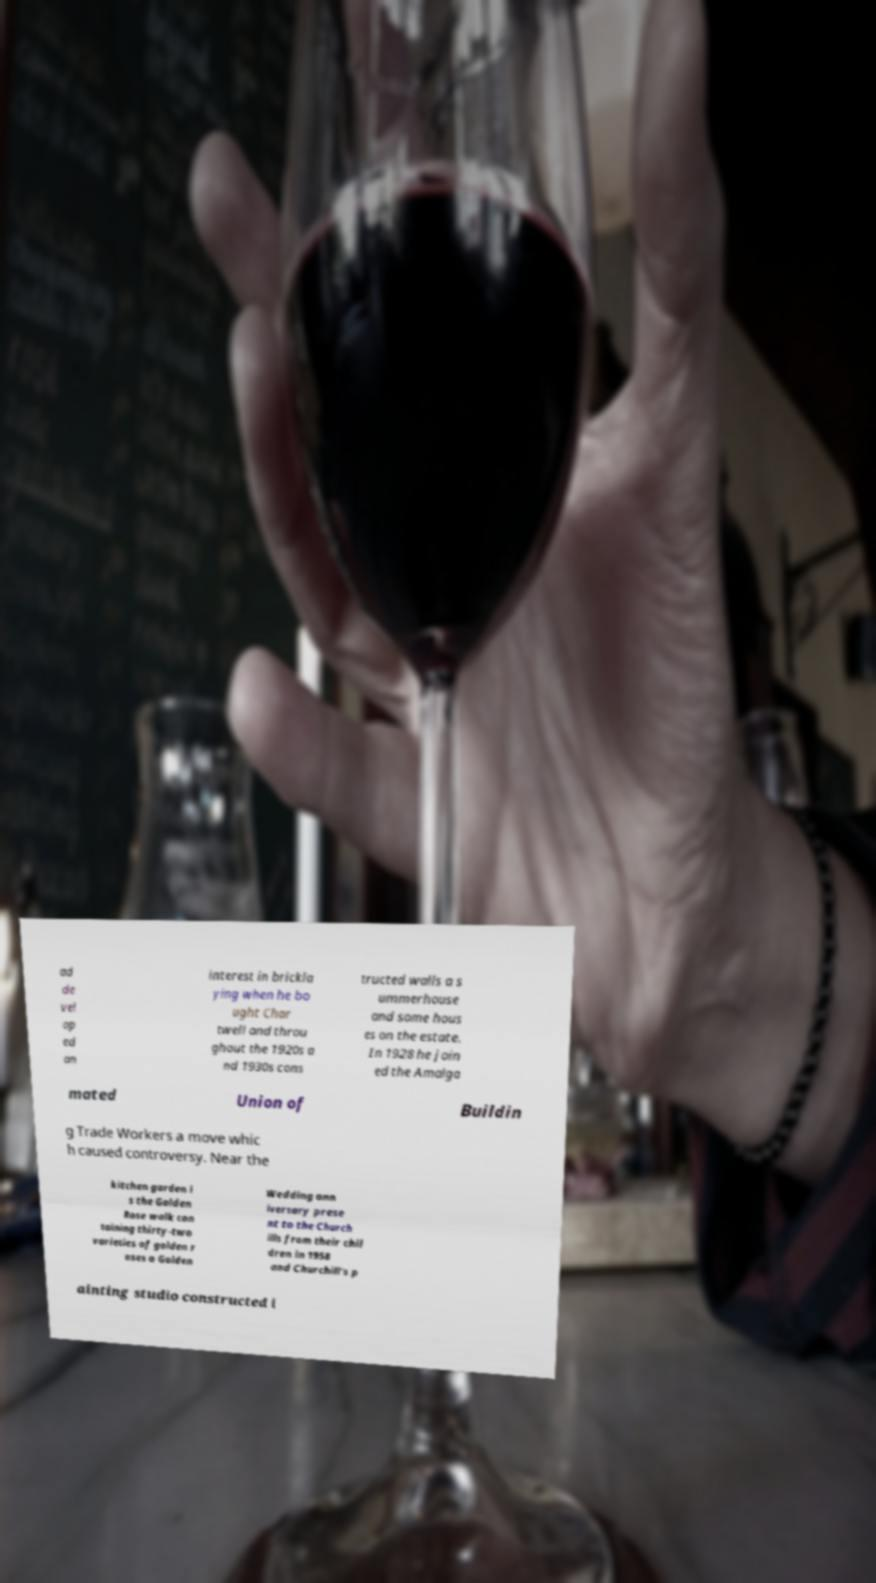Can you accurately transcribe the text from the provided image for me? ad de vel op ed an interest in brickla ying when he bo ught Char twell and throu ghout the 1920s a nd 1930s cons tructed walls a s ummerhouse and some hous es on the estate. In 1928 he join ed the Amalga mated Union of Buildin g Trade Workers a move whic h caused controversy. Near the kitchen garden i s the Golden Rose walk con taining thirty-two varieties of golden r oses a Golden Wedding ann iversary prese nt to the Church ills from their chil dren in 1958 and Churchill's p ainting studio constructed i 